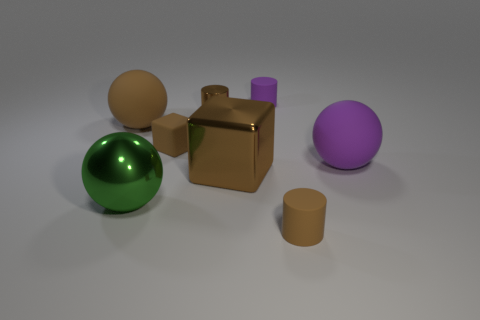What is the material of the small brown cylinder to the left of the small brown cylinder in front of the large brown sphere?
Make the answer very short. Metal. Is the size of the brown rubber cylinder the same as the green thing?
Offer a very short reply. No. How many things are big cyan objects or large purple rubber spheres?
Your answer should be very brief. 1. There is a matte object that is to the left of the small purple rubber cylinder and on the right side of the metal ball; what is its size?
Give a very brief answer. Small. Is the number of objects that are in front of the big green object less than the number of brown metal things?
Your answer should be compact. Yes. There is a small purple object that is the same material as the large brown sphere; what is its shape?
Provide a short and direct response. Cylinder. There is a purple matte object that is behind the rubber block; is its shape the same as the large brown object to the left of the big green sphere?
Offer a very short reply. No. Are there fewer green spheres on the left side of the brown rubber sphere than green metal balls right of the green ball?
Provide a short and direct response. No. What shape is the small metal object that is the same color as the shiny block?
Keep it short and to the point. Cylinder. How many purple objects have the same size as the brown matte block?
Your answer should be very brief. 1. 